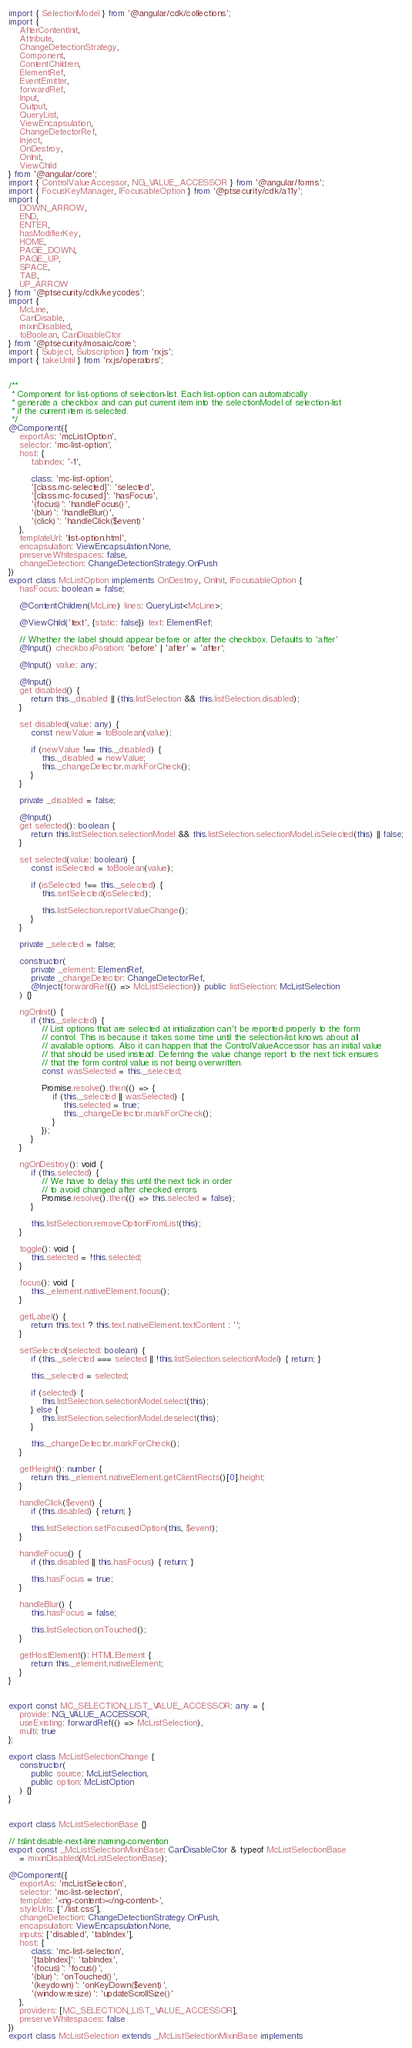Convert code to text. <code><loc_0><loc_0><loc_500><loc_500><_TypeScript_>import { SelectionModel } from '@angular/cdk/collections';
import {
    AfterContentInit,
    Attribute,
    ChangeDetectionStrategy,
    Component,
    ContentChildren,
    ElementRef,
    EventEmitter,
    forwardRef,
    Input,
    Output,
    QueryList,
    ViewEncapsulation,
    ChangeDetectorRef,
    Inject,
    OnDestroy,
    OnInit,
    ViewChild
} from '@angular/core';
import { ControlValueAccessor, NG_VALUE_ACCESSOR } from '@angular/forms';
import { FocusKeyManager, IFocusableOption } from '@ptsecurity/cdk/a11y';
import {
    DOWN_ARROW,
    END,
    ENTER,
    hasModifierKey,
    HOME,
    PAGE_DOWN,
    PAGE_UP,
    SPACE,
    TAB,
    UP_ARROW
} from '@ptsecurity/cdk/keycodes';
import {
    McLine,
    CanDisable,
    mixinDisabled,
    toBoolean, CanDisableCtor
} from '@ptsecurity/mosaic/core';
import { Subject, Subscription } from 'rxjs';
import { takeUntil } from 'rxjs/operators';


/**
 * Component for list-options of selection-list. Each list-option can automatically
 * generate a checkbox and can put current item into the selectionModel of selection-list
 * if the current item is selected.
 */
@Component({
    exportAs: 'mcListOption',
    selector: 'mc-list-option',
    host: {
        tabindex: '-1',

        class: 'mc-list-option',
        '[class.mc-selected]': 'selected',
        '[class.mc-focused]': 'hasFocus',
        '(focus)': 'handleFocus()',
        '(blur)': 'handleBlur()',
        '(click)': 'handleClick($event)'
    },
    templateUrl: 'list-option.html',
    encapsulation: ViewEncapsulation.None,
    preserveWhitespaces: false,
    changeDetection: ChangeDetectionStrategy.OnPush
})
export class McListOption implements OnDestroy, OnInit, IFocusableOption {
    hasFocus: boolean = false;

    @ContentChildren(McLine) lines: QueryList<McLine>;

    @ViewChild('text', {static: false}) text: ElementRef;

    // Whether the label should appear before or after the checkbox. Defaults to 'after'
    @Input() checkboxPosition: 'before' | 'after' = 'after';

    @Input() value: any;

    @Input()
    get disabled() {
        return this._disabled || (this.listSelection && this.listSelection.disabled);
    }

    set disabled(value: any) {
        const newValue = toBoolean(value);

        if (newValue !== this._disabled) {
            this._disabled = newValue;
            this._changeDetector.markForCheck();
        }
    }

    private _disabled = false;

    @Input()
    get selected(): boolean {
        return this.listSelection.selectionModel && this.listSelection.selectionModel.isSelected(this) || false;
    }

    set selected(value: boolean) {
        const isSelected = toBoolean(value);

        if (isSelected !== this._selected) {
            this.setSelected(isSelected);

            this.listSelection.reportValueChange();
        }
    }

    private _selected = false;

    constructor(
        private _element: ElementRef,
        private _changeDetector: ChangeDetectorRef,
        @Inject(forwardRef(() => McListSelection)) public listSelection: McListSelection
    ) {}

    ngOnInit() {
        if (this._selected) {
            // List options that are selected at initialization can't be reported properly to the form
            // control. This is because it takes some time until the selection-list knows about all
            // available options. Also it can happen that the ControlValueAccessor has an initial value
            // that should be used instead. Deferring the value change report to the next tick ensures
            // that the form control value is not being overwritten.
            const wasSelected = this._selected;

            Promise.resolve().then(() => {
                if (this._selected || wasSelected) {
                    this.selected = true;
                    this._changeDetector.markForCheck();
                }
            });
        }
    }

    ngOnDestroy(): void {
        if (this.selected) {
            // We have to delay this until the next tick in order
            // to avoid changed after checked errors.
            Promise.resolve().then(() => this.selected = false);
        }

        this.listSelection.removeOptionFromList(this);
    }

    toggle(): void {
        this.selected = !this.selected;
    }

    focus(): void {
        this._element.nativeElement.focus();
    }

    getLabel() {
        return this.text ? this.text.nativeElement.textContent : '';
    }

    setSelected(selected: boolean) {
        if (this._selected === selected || !this.listSelection.selectionModel) { return; }

        this._selected = selected;

        if (selected) {
            this.listSelection.selectionModel.select(this);
        } else {
            this.listSelection.selectionModel.deselect(this);
        }

        this._changeDetector.markForCheck();
    }

    getHeight(): number {
        return this._element.nativeElement.getClientRects()[0].height;
    }

    handleClick($event) {
        if (this.disabled) { return; }

        this.listSelection.setFocusedOption(this, $event);
    }

    handleFocus() {
        if (this.disabled || this.hasFocus) { return; }

        this.hasFocus = true;
    }

    handleBlur() {
        this.hasFocus = false;

        this.listSelection.onTouched();
    }

    getHostElement(): HTMLElement {
        return this._element.nativeElement;
    }
}


export const MC_SELECTION_LIST_VALUE_ACCESSOR: any = {
    provide: NG_VALUE_ACCESSOR,
    useExisting: forwardRef(() => McListSelection),
    multi: true
};

export class McListSelectionChange {
    constructor(
        public source: McListSelection,
        public option: McListOption
    ) {}
}


export class McListSelectionBase {}

// tslint:disable-next-line:naming-convention
export const _McListSelectionMixinBase: CanDisableCtor & typeof McListSelectionBase
    = mixinDisabled(McListSelectionBase);

@Component({
    exportAs: 'mcListSelection',
    selector: 'mc-list-selection',
    template: '<ng-content></ng-content>',
    styleUrls: ['./list.css'],
    changeDetection: ChangeDetectionStrategy.OnPush,
    encapsulation: ViewEncapsulation.None,
    inputs: ['disabled', 'tabIndex'],
    host: {
        class: 'mc-list-selection',
        '[tabIndex]': 'tabIndex',
        '(focus)': 'focus()',
        '(blur)': 'onTouched()',
        '(keydown)': 'onKeyDown($event)',
        '(window:resize)': 'updateScrollSize()'
    },
    providers: [MC_SELECTION_LIST_VALUE_ACCESSOR],
    preserveWhitespaces: false
})
export class McListSelection extends _McListSelectionMixinBase implements</code> 